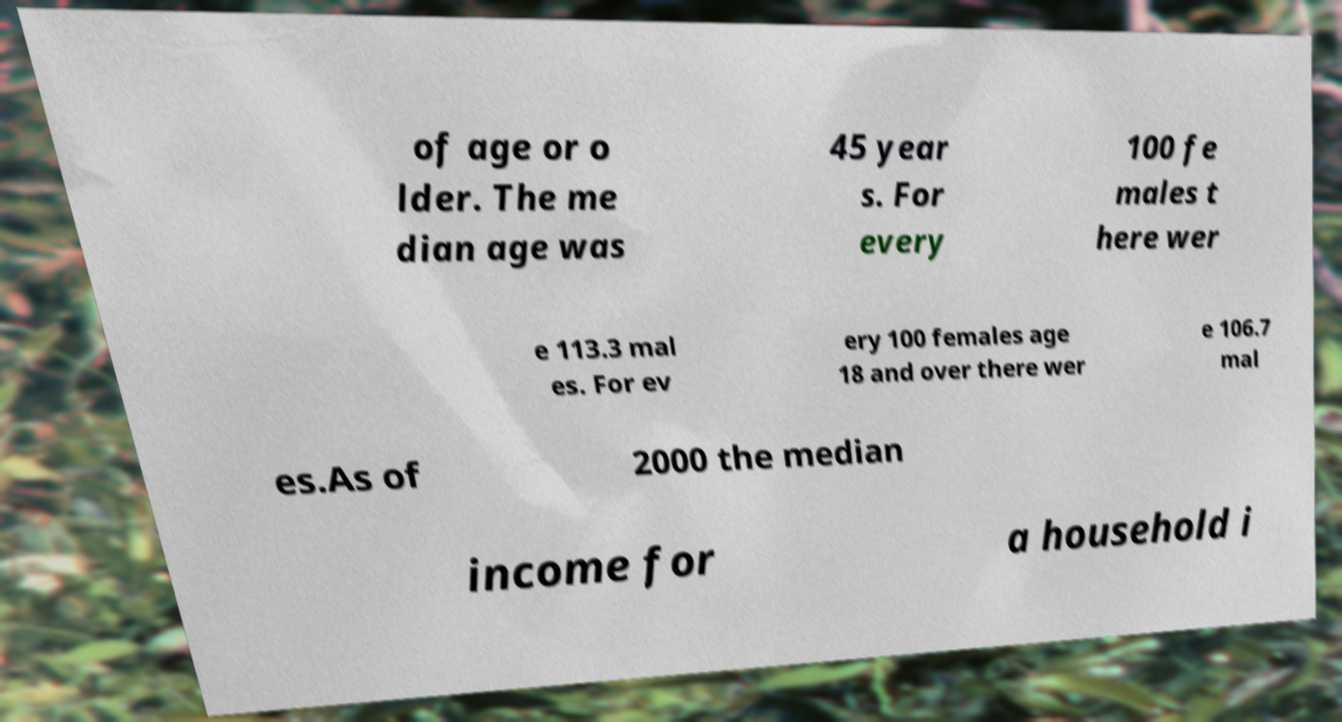Could you assist in decoding the text presented in this image and type it out clearly? of age or o lder. The me dian age was 45 year s. For every 100 fe males t here wer e 113.3 mal es. For ev ery 100 females age 18 and over there wer e 106.7 mal es.As of 2000 the median income for a household i 